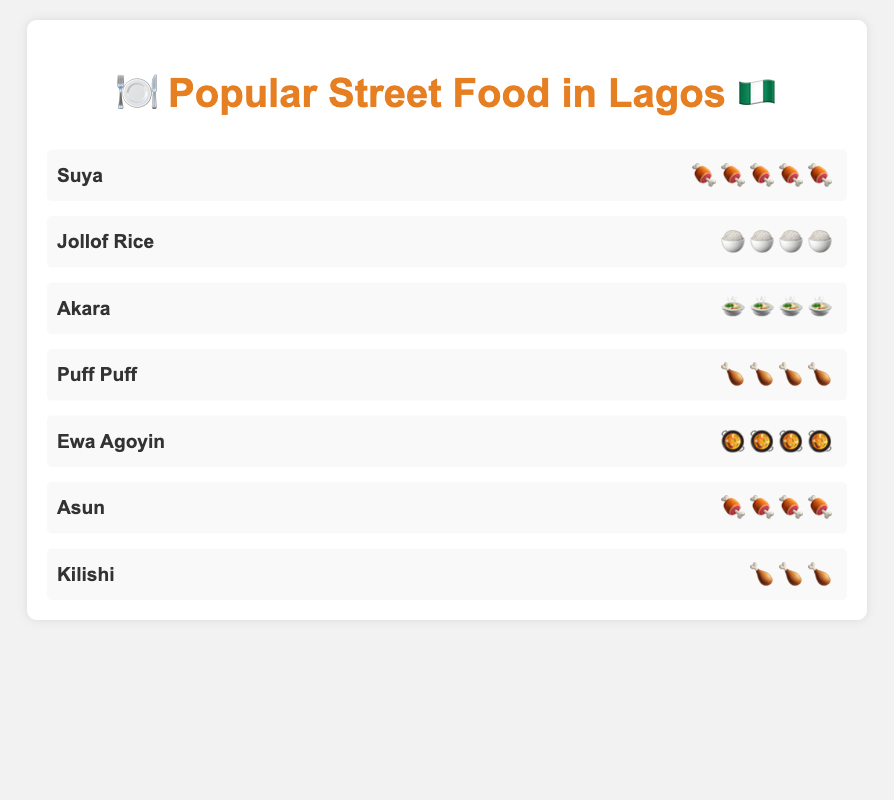What is the highest-rated street food? Suya has the highest rating with five emoji.
Answer: Suya How many food items have exactly four emoji ratings? Jollof Rice, Akara, Puff Puff, Ewa Agoyin, and Asun each have four emoji ratings which makes a total of 5 items.
Answer: 5 Which food item has the lowest rating? Kilishi has three emoji ratings, the lowest among all the food items.
Answer: Kilishi How many different types of emoji are used to represent the ratings? The different types of emoji used are: 🍖, 🍚, 🍲, 🍗, and 🥘.
Answer: 5 What two food items have the same number of rating emoji as Jollof Rice? Both Puff Puff and Ewa Agoyin have the same number of rating emoji as Jollof Rice, which is four.
Answer: Puff Puff, Ewa Agoyin Which two food items share the same rating as Asun? Puff Puff and Ewa Agoyin share the same four emoji rating as Asun.
Answer: Puff Puff, Ewa Agoyin What is the combined rating of Suya and Kilishi? Suya has five emoji and Kilishi has three emoji, so combined they have eight emoji.
Answer: 8 Which street food is rated exactly one emoji less than Suya? Asun is rated one emoji less than Suya with four emoji ratings.
Answer: Asun How many total emoji ratings are there across all the food items? Adding up all the emoji ratings: Suya (5) + Jollof Rice (4) + Akara (4) + Puff Puff (4) + Ewa Agoyin (4) + Asun (4) + Kilishi (3) = 28.
Answer: 28 